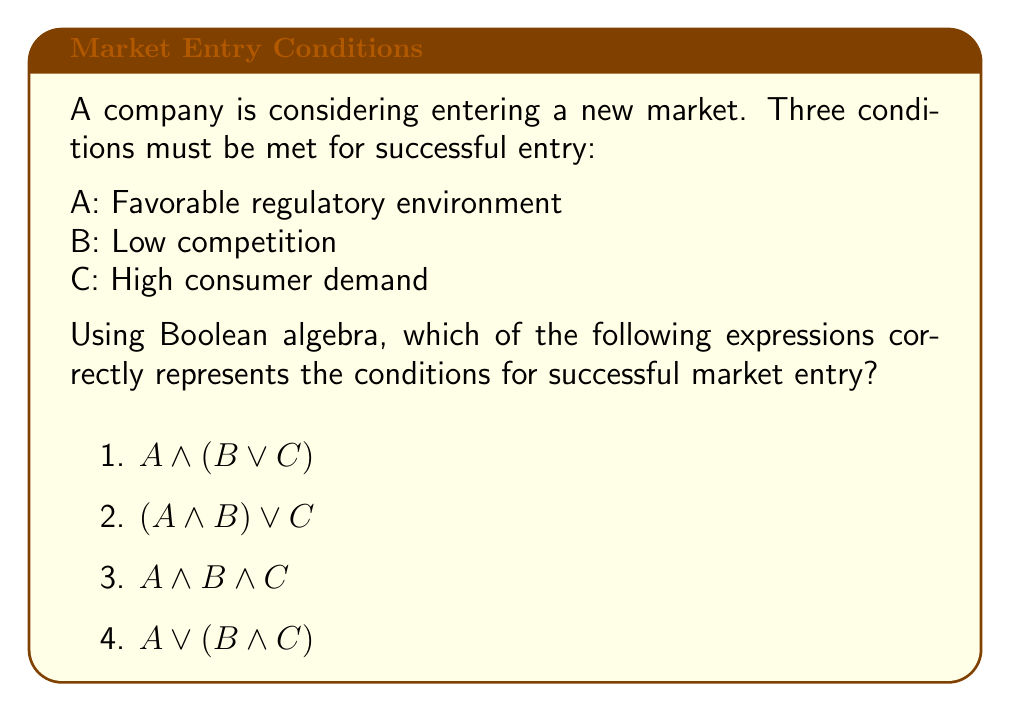Solve this math problem. To analyze this problem using Boolean logic, let's break it down step-by-step:

1) First, we need to understand what the question is asking. We're looking for an expression that represents the conditions for successful market entry, where all three conditions (A, B, and C) must be met.

2) In Boolean algebra, the AND operation ($\land$) is used when all conditions must be true, while the OR operation ($\lor$) is used when at least one condition must be true.

3) Since all three conditions must be met for successful market entry, we need to use the AND operation ($\land$) to connect all three variables.

4) Let's evaluate each option:

   Option 1: $A \land (B \lor C)$
   This means A must be true, and either B or C must be true. This is incorrect because it doesn't require all three conditions to be met.

   Option 2: $(A \land B) \lor C$
   This means either both A and B must be true, or C must be true. This is also incorrect as it doesn't require all three conditions.

   Option 3: $A \land B \land C$
   This means A and B and C must all be true. This correctly represents our requirements.

   Option 4: $A \lor (B \land C)$
   This means either A must be true, or both B and C must be true. This is incorrect as it doesn't require all three conditions.

5) Therefore, the correct expression is option 3: $A \land B \land C$

This expression accurately represents that all three conditions (favorable regulatory environment, low competition, and high consumer demand) must be met for successful market entry.
Answer: $A \land B \land C$ 